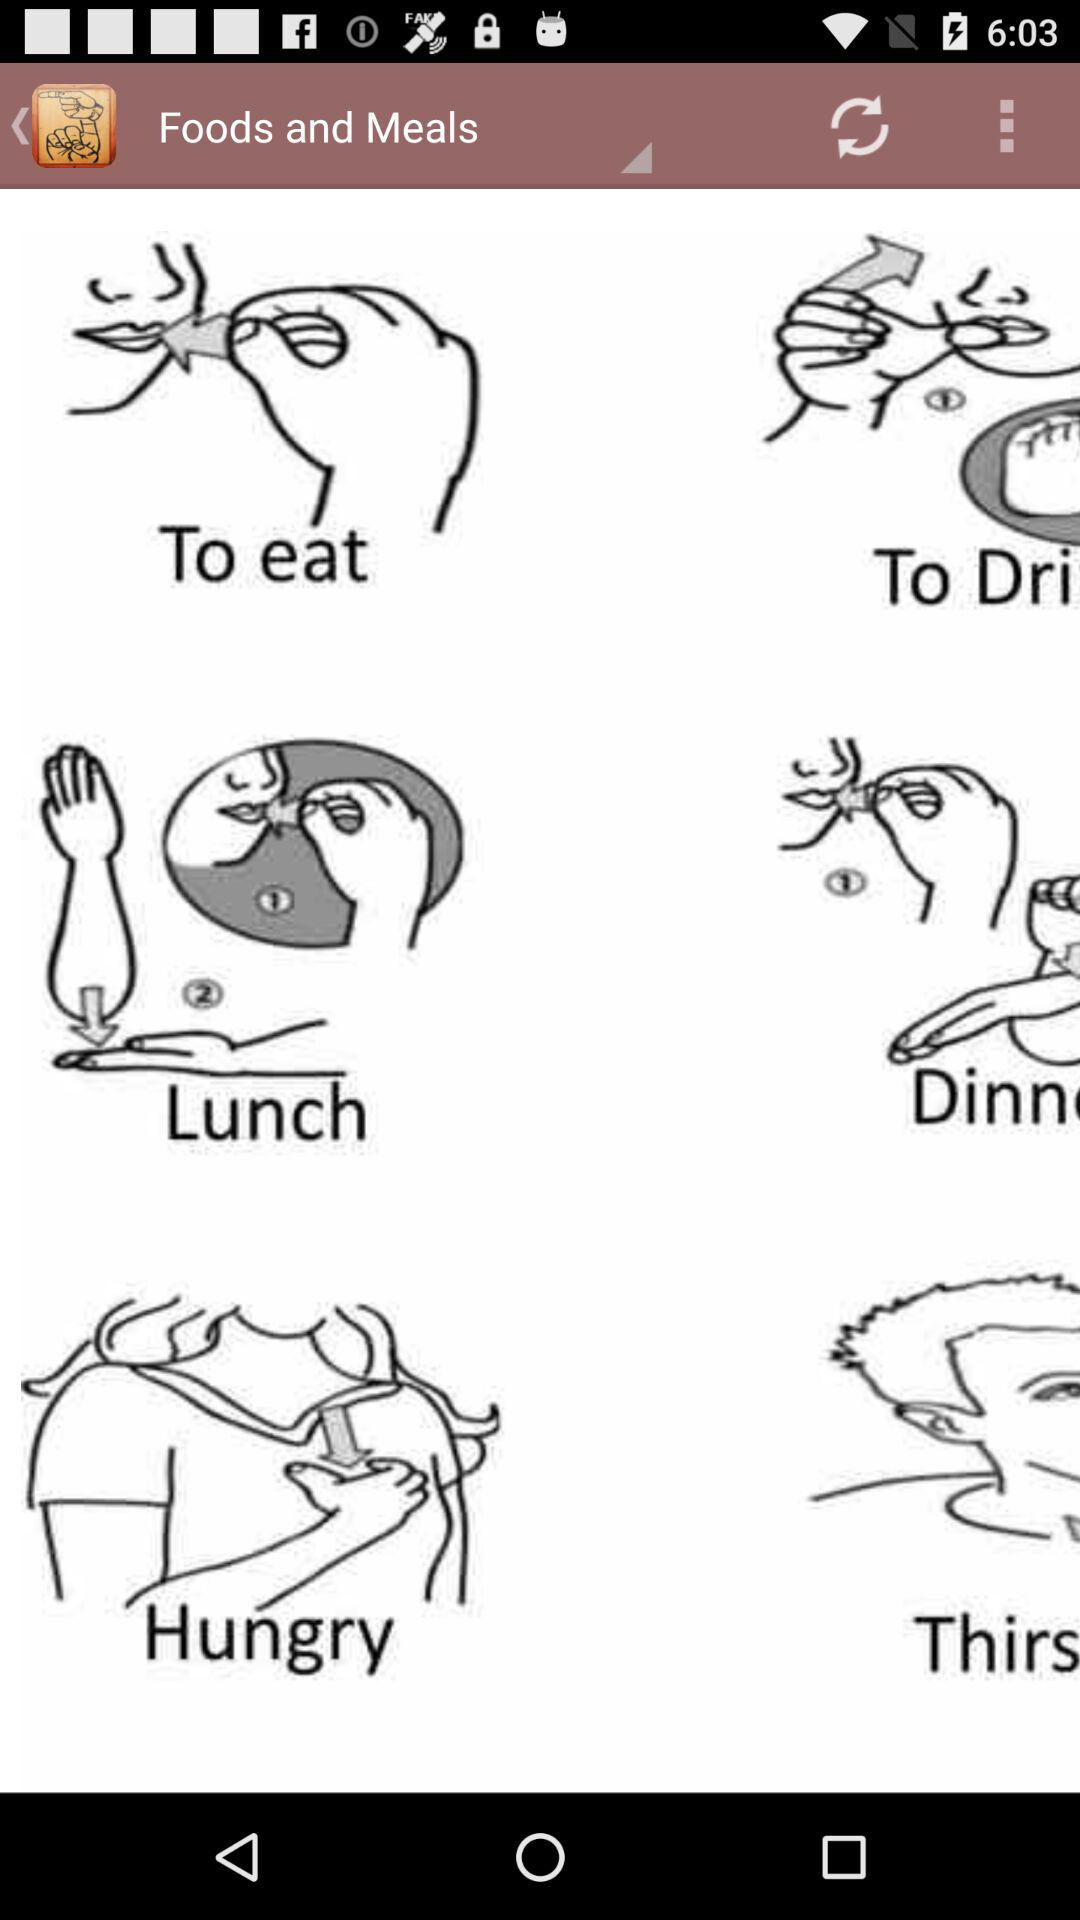What is the value of the drop-down option?
When the provided information is insufficient, respond with <no answer>. <no answer> 